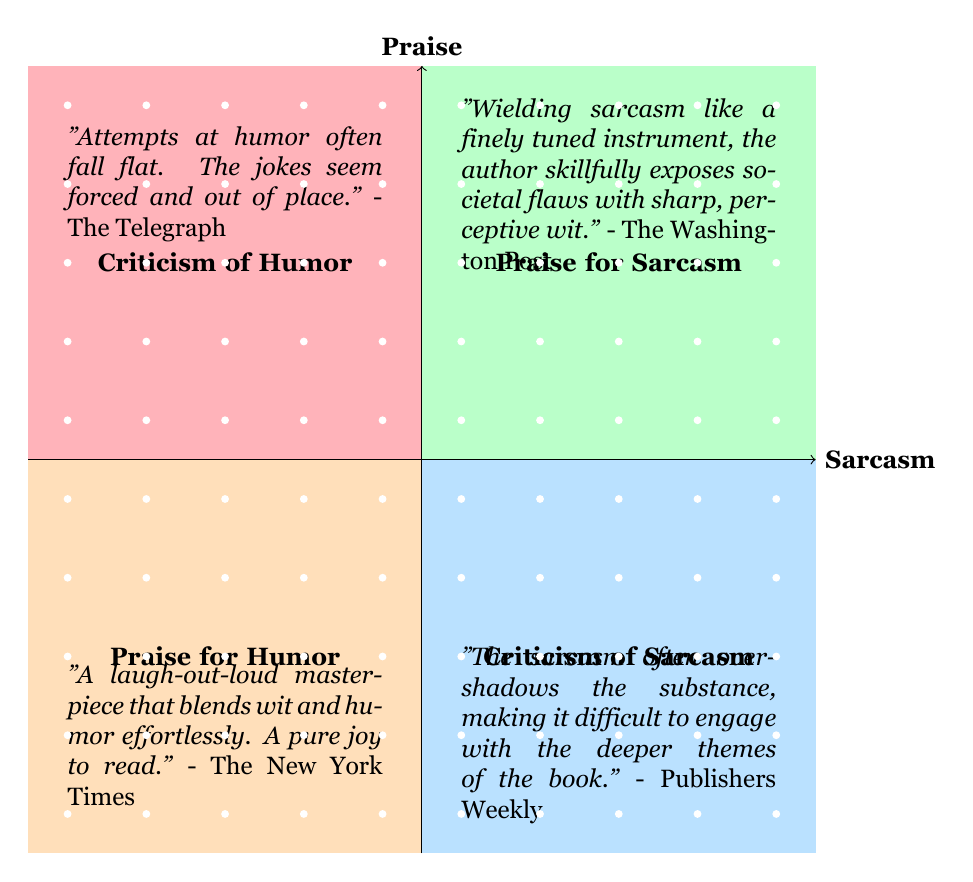What examples are given for Praise of Humor? The quadrant labeled "Praise for Humor" contains quotes illustrating positive reader reactions, specifically mentioning the New York Times and its review describing the work as a "laugh-out-loud masterpiece" and The Guardian, identifying the author as an "astute comedic talent".
Answer: The New York Times and The Guardian What quote is associated with Criticism of Sarcasm? In the quadrant labeled "Criticism of Sarcasm", one example is a quote from Publishers Weekly which states that "The sarcasm often overshadows the substance". This indicates a negative perspective on the use of sarcasm in the work.
Answer: Publishers Weekly How many examples are listed under Praise for Sarcasm? The "Praise for Sarcasm" quadrant contains two distinct examples of positive reviews that highlight the effectiveness of sarcasm, specifically from The Washington Post and Rolling Stone.
Answer: Two Which quadrant features a quote from The Atlantic? The Atlantic's quote is located in the "Criticism of Sarcasm" quadrant, where it expresses the idea that heavy sarcasm can be more caustic than clever, thus negatively reflecting on the use of sarcasm in the work.
Answer: Criticism of Sarcasm What praise is highlighted in the Praise for Sarcasm quadrant? The Praise for Sarcasm quadrant includes a notable quote from Rolling Stone that mentions "the book's sarcasm is both biting and brilliantly executed", showcasing high praise for the author’s use of sarcastic humor.
Answer: Biting and brilliantly executed What is the main criticism found in the Criticism of Humor quadrant? In the "Criticism of Humor" quadrant, one of the criticisms is provided by Kirkus Reviews, which highlights that humor feels "dated and overused", indicating that it detracts from the overall narrative impact.
Answer: Dated and overused What do the axes of the quadrant represent? The horizontal axis of the quadrant chart represents the level of sarcasm, while the vertical axis signifies reader praise. This structure allows for easy positioning of quotes based on reader reactions to humor and sarcasm.
Answer: Sarcasm and Praise Which reviewer suggests that the humor attempts are forced? The quote stating that "Attempts at humor often fall flat" comes from The Telegraph, making it clear that this reviewer found the humor in the work unconvincing and awkwardly placed.
Answer: The Telegraph 